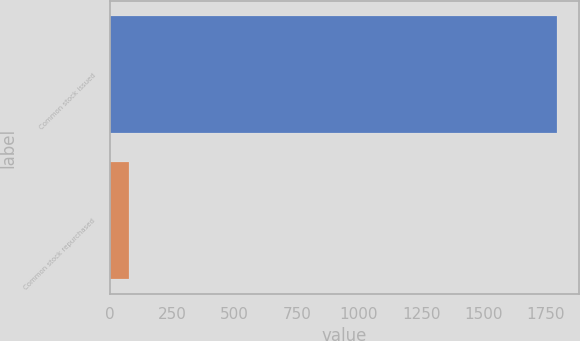Convert chart. <chart><loc_0><loc_0><loc_500><loc_500><bar_chart><fcel>Common stock issued<fcel>Common stock repurchased<nl><fcel>1793<fcel>78<nl></chart> 